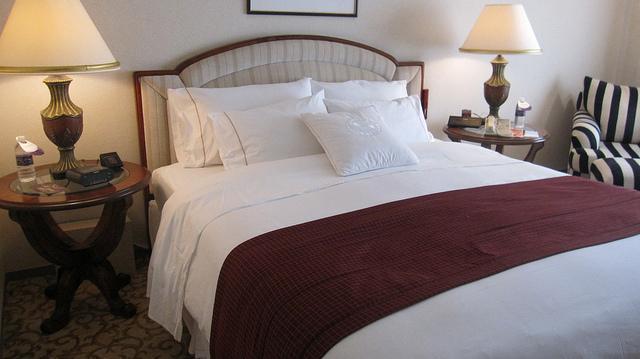How many lamps are there?
Give a very brief answer. 2. How many chairs can be seen?
Give a very brief answer. 1. 